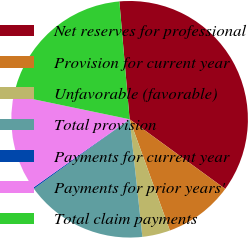Convert chart. <chart><loc_0><loc_0><loc_500><loc_500><pie_chart><fcel>Net reserves for professional<fcel>Provision for current year<fcel>Unfavorable (favorable)<fcel>Total provision<fcel>Payments for current year<fcel>Payments for prior years'<fcel>Total claim payments<nl><fcel>36.4%<fcel>9.45%<fcel>3.81%<fcel>16.72%<fcel>0.18%<fcel>13.09%<fcel>20.35%<nl></chart> 